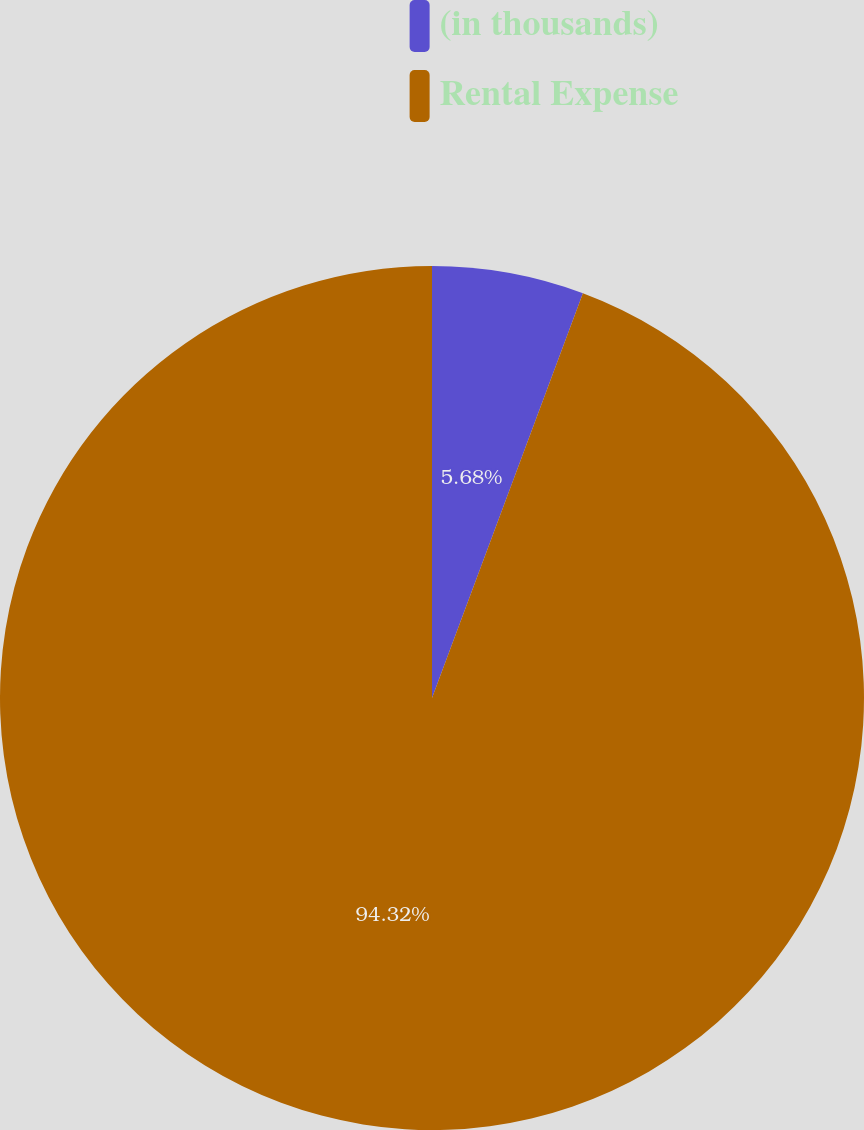Convert chart to OTSL. <chart><loc_0><loc_0><loc_500><loc_500><pie_chart><fcel>(in thousands)<fcel>Rental Expense<nl><fcel>5.68%<fcel>94.32%<nl></chart> 